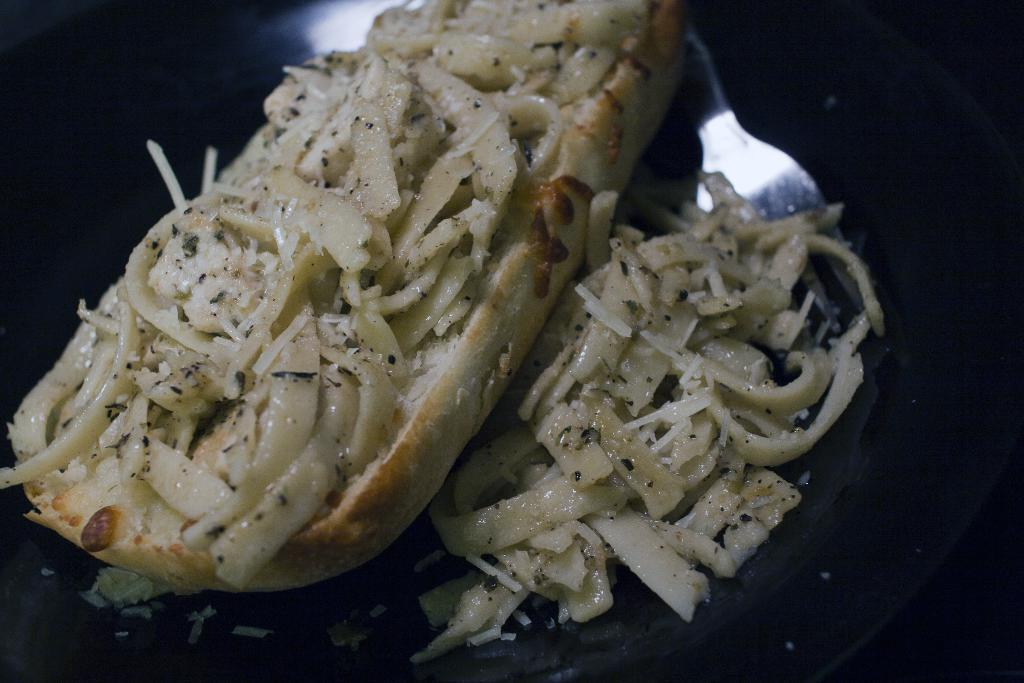What is on the plate in the image? There is food on a plate in the image. Can you describe the background of the image? The background of the image is dark. Are there any visible cobwebs in the image? There is no mention of cobwebs in the provided facts, so we cannot determine if they are present in the image. 